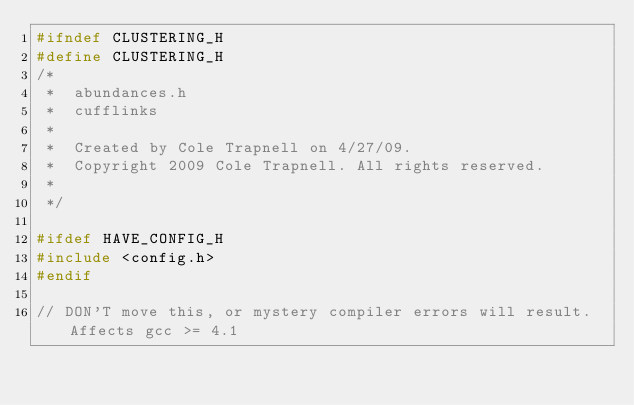Convert code to text. <code><loc_0><loc_0><loc_500><loc_500><_C_>#ifndef CLUSTERING_H
#define CLUSTERING_H
/*
 *  abundances.h
 *  cufflinks
 *
 *  Created by Cole Trapnell on 4/27/09.
 *  Copyright 2009 Cole Trapnell. All rights reserved.
 *
 */

#ifdef HAVE_CONFIG_H
#include <config.h>
#endif

// DON'T move this, or mystery compiler errors will result. Affects gcc >= 4.1</code> 